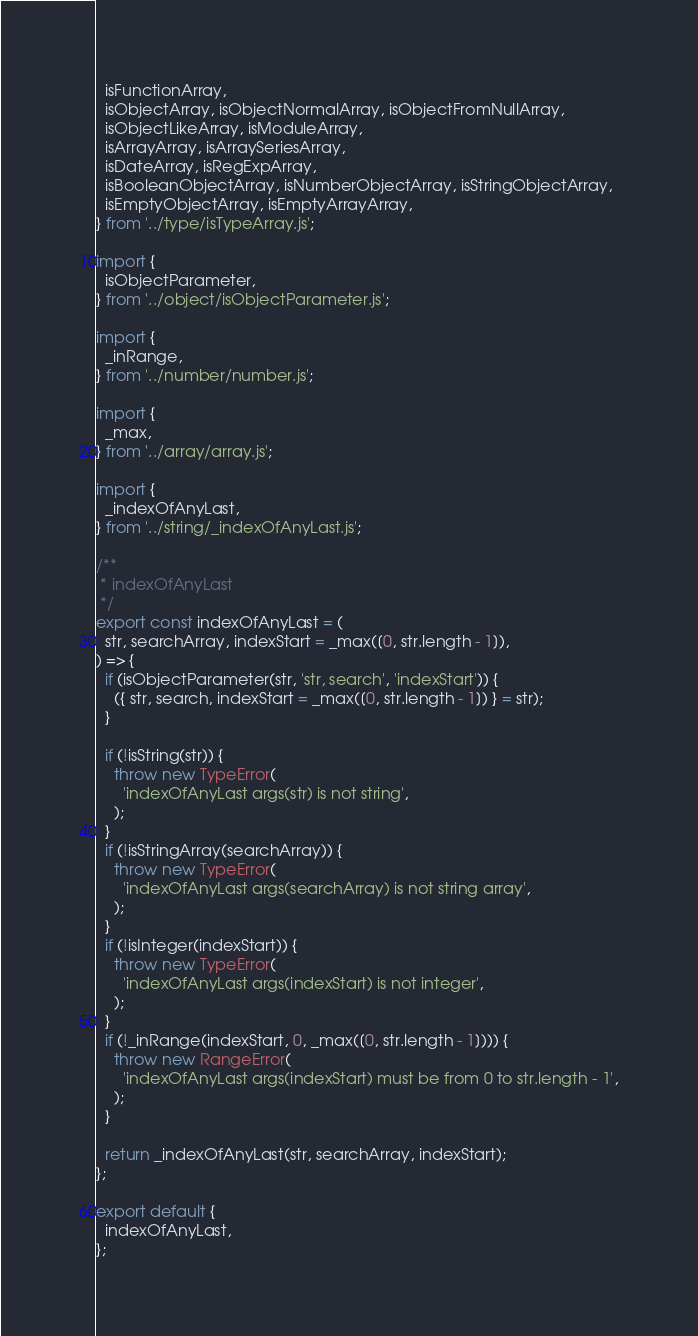Convert code to text. <code><loc_0><loc_0><loc_500><loc_500><_JavaScript_>  isFunctionArray,
  isObjectArray, isObjectNormalArray, isObjectFromNullArray,
  isObjectLikeArray, isModuleArray,
  isArrayArray, isArraySeriesArray,
  isDateArray, isRegExpArray,
  isBooleanObjectArray, isNumberObjectArray, isStringObjectArray,
  isEmptyObjectArray, isEmptyArrayArray,
} from '../type/isTypeArray.js';

import {
  isObjectParameter,
} from '../object/isObjectParameter.js';

import {
  _inRange,
} from '../number/number.js';

import {
  _max,
} from '../array/array.js';

import {
  _indexOfAnyLast,
} from '../string/_indexOfAnyLast.js';

/**
 * indexOfAnyLast
 */
export const indexOfAnyLast = (
  str, searchArray, indexStart = _max([0, str.length - 1]),
) => {
  if (isObjectParameter(str, 'str, search', 'indexStart')) {
    ({ str, search, indexStart = _max([0, str.length - 1]) } = str);
  }

  if (!isString(str)) {
    throw new TypeError(
      'indexOfAnyLast args(str) is not string',
    );
  }
  if (!isStringArray(searchArray)) {
    throw new TypeError(
      'indexOfAnyLast args(searchArray) is not string array',
    );
  }
  if (!isInteger(indexStart)) {
    throw new TypeError(
      'indexOfAnyLast args(indexStart) is not integer',
    );
  }
  if (!_inRange(indexStart, 0, _max([0, str.length - 1]))) {
    throw new RangeError(
      'indexOfAnyLast args(indexStart) must be from 0 to str.length - 1',
    );
  }

  return _indexOfAnyLast(str, searchArray, indexStart);
};

export default {
  indexOfAnyLast,
};
</code> 